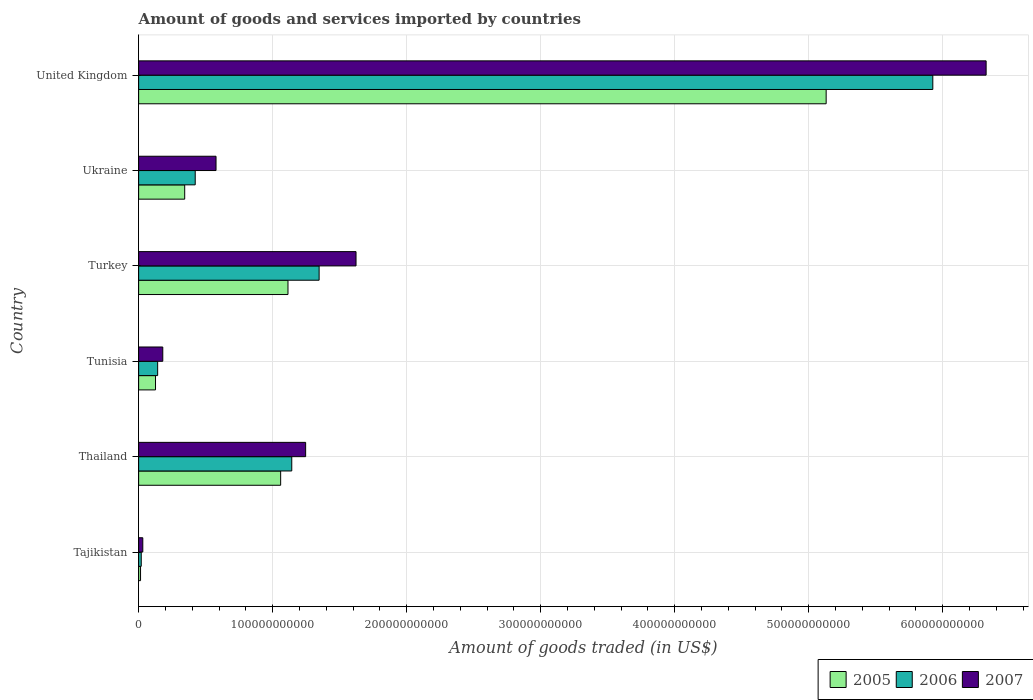Are the number of bars on each tick of the Y-axis equal?
Offer a very short reply. Yes. How many bars are there on the 1st tick from the top?
Provide a short and direct response. 3. How many bars are there on the 4th tick from the bottom?
Your answer should be compact. 3. What is the label of the 2nd group of bars from the top?
Keep it short and to the point. Ukraine. In how many cases, is the number of bars for a given country not equal to the number of legend labels?
Offer a terse response. 0. What is the total amount of goods and services imported in 2005 in Tunisia?
Give a very brief answer. 1.26e+1. Across all countries, what is the maximum total amount of goods and services imported in 2007?
Your response must be concise. 6.32e+11. Across all countries, what is the minimum total amount of goods and services imported in 2005?
Offer a terse response. 1.43e+09. In which country was the total amount of goods and services imported in 2007 minimum?
Offer a very short reply. Tajikistan. What is the total total amount of goods and services imported in 2005 in the graph?
Offer a very short reply. 7.79e+11. What is the difference between the total amount of goods and services imported in 2007 in Tunisia and that in Ukraine?
Provide a succinct answer. -3.97e+1. What is the difference between the total amount of goods and services imported in 2006 in Turkey and the total amount of goods and services imported in 2005 in Tajikistan?
Offer a terse response. 1.33e+11. What is the average total amount of goods and services imported in 2007 per country?
Provide a succinct answer. 1.66e+11. What is the difference between the total amount of goods and services imported in 2006 and total amount of goods and services imported in 2005 in Tajikistan?
Give a very brief answer. 5.24e+08. What is the ratio of the total amount of goods and services imported in 2007 in Ukraine to that in United Kingdom?
Your answer should be compact. 0.09. What is the difference between the highest and the second highest total amount of goods and services imported in 2007?
Offer a terse response. 4.70e+11. What is the difference between the highest and the lowest total amount of goods and services imported in 2005?
Make the answer very short. 5.12e+11. In how many countries, is the total amount of goods and services imported in 2005 greater than the average total amount of goods and services imported in 2005 taken over all countries?
Give a very brief answer. 1. What does the 1st bar from the top in United Kingdom represents?
Make the answer very short. 2007. Is it the case that in every country, the sum of the total amount of goods and services imported in 2007 and total amount of goods and services imported in 2006 is greater than the total amount of goods and services imported in 2005?
Offer a very short reply. Yes. Are all the bars in the graph horizontal?
Give a very brief answer. Yes. What is the difference between two consecutive major ticks on the X-axis?
Provide a succinct answer. 1.00e+11. Does the graph contain any zero values?
Provide a short and direct response. No. Does the graph contain grids?
Keep it short and to the point. Yes. Where does the legend appear in the graph?
Keep it short and to the point. Bottom right. How are the legend labels stacked?
Give a very brief answer. Horizontal. What is the title of the graph?
Offer a very short reply. Amount of goods and services imported by countries. Does "1999" appear as one of the legend labels in the graph?
Provide a succinct answer. No. What is the label or title of the X-axis?
Make the answer very short. Amount of goods traded (in US$). What is the label or title of the Y-axis?
Offer a terse response. Country. What is the Amount of goods traded (in US$) of 2005 in Tajikistan?
Keep it short and to the point. 1.43e+09. What is the Amount of goods traded (in US$) of 2006 in Tajikistan?
Your response must be concise. 1.95e+09. What is the Amount of goods traded (in US$) of 2007 in Tajikistan?
Your response must be concise. 3.12e+09. What is the Amount of goods traded (in US$) of 2005 in Thailand?
Make the answer very short. 1.06e+11. What is the Amount of goods traded (in US$) of 2006 in Thailand?
Give a very brief answer. 1.14e+11. What is the Amount of goods traded (in US$) in 2007 in Thailand?
Your response must be concise. 1.25e+11. What is the Amount of goods traded (in US$) in 2005 in Tunisia?
Your response must be concise. 1.26e+1. What is the Amount of goods traded (in US$) of 2006 in Tunisia?
Offer a very short reply. 1.42e+1. What is the Amount of goods traded (in US$) of 2007 in Tunisia?
Your response must be concise. 1.80e+1. What is the Amount of goods traded (in US$) of 2005 in Turkey?
Offer a very short reply. 1.11e+11. What is the Amount of goods traded (in US$) in 2006 in Turkey?
Keep it short and to the point. 1.35e+11. What is the Amount of goods traded (in US$) of 2007 in Turkey?
Give a very brief answer. 1.62e+11. What is the Amount of goods traded (in US$) in 2005 in Ukraine?
Provide a succinct answer. 3.44e+1. What is the Amount of goods traded (in US$) of 2006 in Ukraine?
Your answer should be compact. 4.22e+1. What is the Amount of goods traded (in US$) of 2007 in Ukraine?
Your answer should be very brief. 5.78e+1. What is the Amount of goods traded (in US$) in 2005 in United Kingdom?
Ensure brevity in your answer.  5.13e+11. What is the Amount of goods traded (in US$) of 2006 in United Kingdom?
Keep it short and to the point. 5.93e+11. What is the Amount of goods traded (in US$) in 2007 in United Kingdom?
Keep it short and to the point. 6.32e+11. Across all countries, what is the maximum Amount of goods traded (in US$) in 2005?
Provide a short and direct response. 5.13e+11. Across all countries, what is the maximum Amount of goods traded (in US$) in 2006?
Provide a succinct answer. 5.93e+11. Across all countries, what is the maximum Amount of goods traded (in US$) in 2007?
Provide a succinct answer. 6.32e+11. Across all countries, what is the minimum Amount of goods traded (in US$) in 2005?
Provide a succinct answer. 1.43e+09. Across all countries, what is the minimum Amount of goods traded (in US$) of 2006?
Provide a succinct answer. 1.95e+09. Across all countries, what is the minimum Amount of goods traded (in US$) in 2007?
Your answer should be compact. 3.12e+09. What is the total Amount of goods traded (in US$) in 2005 in the graph?
Ensure brevity in your answer.  7.79e+11. What is the total Amount of goods traded (in US$) in 2006 in the graph?
Your answer should be very brief. 9.00e+11. What is the total Amount of goods traded (in US$) in 2007 in the graph?
Ensure brevity in your answer.  9.98e+11. What is the difference between the Amount of goods traded (in US$) of 2005 in Tajikistan and that in Thailand?
Make the answer very short. -1.05e+11. What is the difference between the Amount of goods traded (in US$) in 2006 in Tajikistan and that in Thailand?
Keep it short and to the point. -1.12e+11. What is the difference between the Amount of goods traded (in US$) in 2007 in Tajikistan and that in Thailand?
Make the answer very short. -1.21e+11. What is the difference between the Amount of goods traded (in US$) in 2005 in Tajikistan and that in Tunisia?
Offer a terse response. -1.12e+1. What is the difference between the Amount of goods traded (in US$) of 2006 in Tajikistan and that in Tunisia?
Your answer should be compact. -1.22e+1. What is the difference between the Amount of goods traded (in US$) of 2007 in Tajikistan and that in Tunisia?
Offer a terse response. -1.49e+1. What is the difference between the Amount of goods traded (in US$) in 2005 in Tajikistan and that in Turkey?
Provide a short and direct response. -1.10e+11. What is the difference between the Amount of goods traded (in US$) in 2006 in Tajikistan and that in Turkey?
Your answer should be very brief. -1.33e+11. What is the difference between the Amount of goods traded (in US$) of 2007 in Tajikistan and that in Turkey?
Make the answer very short. -1.59e+11. What is the difference between the Amount of goods traded (in US$) of 2005 in Tajikistan and that in Ukraine?
Your answer should be compact. -3.29e+1. What is the difference between the Amount of goods traded (in US$) of 2006 in Tajikistan and that in Ukraine?
Your answer should be compact. -4.03e+1. What is the difference between the Amount of goods traded (in US$) of 2007 in Tajikistan and that in Ukraine?
Your answer should be compact. -5.46e+1. What is the difference between the Amount of goods traded (in US$) of 2005 in Tajikistan and that in United Kingdom?
Ensure brevity in your answer.  -5.12e+11. What is the difference between the Amount of goods traded (in US$) in 2006 in Tajikistan and that in United Kingdom?
Give a very brief answer. -5.91e+11. What is the difference between the Amount of goods traded (in US$) in 2007 in Tajikistan and that in United Kingdom?
Offer a very short reply. -6.29e+11. What is the difference between the Amount of goods traded (in US$) in 2005 in Thailand and that in Tunisia?
Provide a short and direct response. 9.34e+1. What is the difference between the Amount of goods traded (in US$) in 2006 in Thailand and that in Tunisia?
Give a very brief answer. 1.00e+11. What is the difference between the Amount of goods traded (in US$) in 2007 in Thailand and that in Tunisia?
Your response must be concise. 1.07e+11. What is the difference between the Amount of goods traded (in US$) of 2005 in Thailand and that in Turkey?
Offer a very short reply. -5.47e+09. What is the difference between the Amount of goods traded (in US$) in 2006 in Thailand and that in Turkey?
Your answer should be very brief. -2.04e+1. What is the difference between the Amount of goods traded (in US$) in 2007 in Thailand and that in Turkey?
Your answer should be compact. -3.76e+1. What is the difference between the Amount of goods traded (in US$) of 2005 in Thailand and that in Ukraine?
Your answer should be compact. 7.16e+1. What is the difference between the Amount of goods traded (in US$) of 2006 in Thailand and that in Ukraine?
Offer a terse response. 7.20e+1. What is the difference between the Amount of goods traded (in US$) in 2007 in Thailand and that in Ukraine?
Give a very brief answer. 6.69e+1. What is the difference between the Amount of goods traded (in US$) of 2005 in Thailand and that in United Kingdom?
Provide a succinct answer. -4.07e+11. What is the difference between the Amount of goods traded (in US$) of 2006 in Thailand and that in United Kingdom?
Offer a very short reply. -4.78e+11. What is the difference between the Amount of goods traded (in US$) of 2007 in Thailand and that in United Kingdom?
Offer a very short reply. -5.08e+11. What is the difference between the Amount of goods traded (in US$) in 2005 in Tunisia and that in Turkey?
Keep it short and to the point. -9.89e+1. What is the difference between the Amount of goods traded (in US$) in 2006 in Tunisia and that in Turkey?
Offer a very short reply. -1.20e+11. What is the difference between the Amount of goods traded (in US$) in 2007 in Tunisia and that in Turkey?
Your response must be concise. -1.44e+11. What is the difference between the Amount of goods traded (in US$) of 2005 in Tunisia and that in Ukraine?
Offer a very short reply. -2.18e+1. What is the difference between the Amount of goods traded (in US$) of 2006 in Tunisia and that in Ukraine?
Provide a short and direct response. -2.80e+1. What is the difference between the Amount of goods traded (in US$) of 2007 in Tunisia and that in Ukraine?
Your answer should be compact. -3.97e+1. What is the difference between the Amount of goods traded (in US$) of 2005 in Tunisia and that in United Kingdom?
Offer a terse response. -5.00e+11. What is the difference between the Amount of goods traded (in US$) in 2006 in Tunisia and that in United Kingdom?
Offer a terse response. -5.78e+11. What is the difference between the Amount of goods traded (in US$) in 2007 in Tunisia and that in United Kingdom?
Give a very brief answer. -6.14e+11. What is the difference between the Amount of goods traded (in US$) of 2005 in Turkey and that in Ukraine?
Offer a very short reply. 7.71e+1. What is the difference between the Amount of goods traded (in US$) of 2006 in Turkey and that in Ukraine?
Ensure brevity in your answer.  9.25e+1. What is the difference between the Amount of goods traded (in US$) of 2007 in Turkey and that in Ukraine?
Offer a terse response. 1.04e+11. What is the difference between the Amount of goods traded (in US$) of 2005 in Turkey and that in United Kingdom?
Give a very brief answer. -4.02e+11. What is the difference between the Amount of goods traded (in US$) of 2006 in Turkey and that in United Kingdom?
Ensure brevity in your answer.  -4.58e+11. What is the difference between the Amount of goods traded (in US$) of 2007 in Turkey and that in United Kingdom?
Give a very brief answer. -4.70e+11. What is the difference between the Amount of goods traded (in US$) of 2005 in Ukraine and that in United Kingdom?
Your response must be concise. -4.79e+11. What is the difference between the Amount of goods traded (in US$) of 2006 in Ukraine and that in United Kingdom?
Your response must be concise. -5.50e+11. What is the difference between the Amount of goods traded (in US$) in 2007 in Ukraine and that in United Kingdom?
Your answer should be compact. -5.75e+11. What is the difference between the Amount of goods traded (in US$) of 2005 in Tajikistan and the Amount of goods traded (in US$) of 2006 in Thailand?
Your response must be concise. -1.13e+11. What is the difference between the Amount of goods traded (in US$) of 2005 in Tajikistan and the Amount of goods traded (in US$) of 2007 in Thailand?
Give a very brief answer. -1.23e+11. What is the difference between the Amount of goods traded (in US$) in 2006 in Tajikistan and the Amount of goods traded (in US$) in 2007 in Thailand?
Provide a short and direct response. -1.23e+11. What is the difference between the Amount of goods traded (in US$) of 2005 in Tajikistan and the Amount of goods traded (in US$) of 2006 in Tunisia?
Keep it short and to the point. -1.28e+1. What is the difference between the Amount of goods traded (in US$) in 2005 in Tajikistan and the Amount of goods traded (in US$) in 2007 in Tunisia?
Provide a short and direct response. -1.66e+1. What is the difference between the Amount of goods traded (in US$) of 2006 in Tajikistan and the Amount of goods traded (in US$) of 2007 in Tunisia?
Ensure brevity in your answer.  -1.61e+1. What is the difference between the Amount of goods traded (in US$) of 2005 in Tajikistan and the Amount of goods traded (in US$) of 2006 in Turkey?
Offer a terse response. -1.33e+11. What is the difference between the Amount of goods traded (in US$) of 2005 in Tajikistan and the Amount of goods traded (in US$) of 2007 in Turkey?
Make the answer very short. -1.61e+11. What is the difference between the Amount of goods traded (in US$) of 2006 in Tajikistan and the Amount of goods traded (in US$) of 2007 in Turkey?
Make the answer very short. -1.60e+11. What is the difference between the Amount of goods traded (in US$) in 2005 in Tajikistan and the Amount of goods traded (in US$) in 2006 in Ukraine?
Keep it short and to the point. -4.08e+1. What is the difference between the Amount of goods traded (in US$) of 2005 in Tajikistan and the Amount of goods traded (in US$) of 2007 in Ukraine?
Offer a very short reply. -5.63e+1. What is the difference between the Amount of goods traded (in US$) in 2006 in Tajikistan and the Amount of goods traded (in US$) in 2007 in Ukraine?
Offer a very short reply. -5.58e+1. What is the difference between the Amount of goods traded (in US$) in 2005 in Tajikistan and the Amount of goods traded (in US$) in 2006 in United Kingdom?
Your answer should be very brief. -5.91e+11. What is the difference between the Amount of goods traded (in US$) in 2005 in Tajikistan and the Amount of goods traded (in US$) in 2007 in United Kingdom?
Your answer should be compact. -6.31e+11. What is the difference between the Amount of goods traded (in US$) in 2006 in Tajikistan and the Amount of goods traded (in US$) in 2007 in United Kingdom?
Your answer should be compact. -6.30e+11. What is the difference between the Amount of goods traded (in US$) in 2005 in Thailand and the Amount of goods traded (in US$) in 2006 in Tunisia?
Ensure brevity in your answer.  9.18e+1. What is the difference between the Amount of goods traded (in US$) in 2005 in Thailand and the Amount of goods traded (in US$) in 2007 in Tunisia?
Ensure brevity in your answer.  8.80e+1. What is the difference between the Amount of goods traded (in US$) of 2006 in Thailand and the Amount of goods traded (in US$) of 2007 in Tunisia?
Make the answer very short. 9.62e+1. What is the difference between the Amount of goods traded (in US$) in 2005 in Thailand and the Amount of goods traded (in US$) in 2006 in Turkey?
Ensure brevity in your answer.  -2.87e+1. What is the difference between the Amount of goods traded (in US$) in 2005 in Thailand and the Amount of goods traded (in US$) in 2007 in Turkey?
Your answer should be very brief. -5.62e+1. What is the difference between the Amount of goods traded (in US$) of 2006 in Thailand and the Amount of goods traded (in US$) of 2007 in Turkey?
Your answer should be very brief. -4.79e+1. What is the difference between the Amount of goods traded (in US$) in 2005 in Thailand and the Amount of goods traded (in US$) in 2006 in Ukraine?
Provide a succinct answer. 6.38e+1. What is the difference between the Amount of goods traded (in US$) in 2005 in Thailand and the Amount of goods traded (in US$) in 2007 in Ukraine?
Offer a terse response. 4.82e+1. What is the difference between the Amount of goods traded (in US$) in 2006 in Thailand and the Amount of goods traded (in US$) in 2007 in Ukraine?
Provide a short and direct response. 5.65e+1. What is the difference between the Amount of goods traded (in US$) of 2005 in Thailand and the Amount of goods traded (in US$) of 2006 in United Kingdom?
Keep it short and to the point. -4.87e+11. What is the difference between the Amount of goods traded (in US$) of 2005 in Thailand and the Amount of goods traded (in US$) of 2007 in United Kingdom?
Offer a terse response. -5.26e+11. What is the difference between the Amount of goods traded (in US$) in 2006 in Thailand and the Amount of goods traded (in US$) in 2007 in United Kingdom?
Your answer should be compact. -5.18e+11. What is the difference between the Amount of goods traded (in US$) of 2005 in Tunisia and the Amount of goods traded (in US$) of 2006 in Turkey?
Provide a succinct answer. -1.22e+11. What is the difference between the Amount of goods traded (in US$) in 2005 in Tunisia and the Amount of goods traded (in US$) in 2007 in Turkey?
Your answer should be very brief. -1.50e+11. What is the difference between the Amount of goods traded (in US$) in 2006 in Tunisia and the Amount of goods traded (in US$) in 2007 in Turkey?
Offer a terse response. -1.48e+11. What is the difference between the Amount of goods traded (in US$) in 2005 in Tunisia and the Amount of goods traded (in US$) in 2006 in Ukraine?
Offer a terse response. -2.96e+1. What is the difference between the Amount of goods traded (in US$) of 2005 in Tunisia and the Amount of goods traded (in US$) of 2007 in Ukraine?
Ensure brevity in your answer.  -4.52e+1. What is the difference between the Amount of goods traded (in US$) of 2006 in Tunisia and the Amount of goods traded (in US$) of 2007 in Ukraine?
Your answer should be compact. -4.36e+1. What is the difference between the Amount of goods traded (in US$) in 2005 in Tunisia and the Amount of goods traded (in US$) in 2006 in United Kingdom?
Offer a very short reply. -5.80e+11. What is the difference between the Amount of goods traded (in US$) in 2005 in Tunisia and the Amount of goods traded (in US$) in 2007 in United Kingdom?
Provide a succinct answer. -6.20e+11. What is the difference between the Amount of goods traded (in US$) of 2006 in Tunisia and the Amount of goods traded (in US$) of 2007 in United Kingdom?
Give a very brief answer. -6.18e+11. What is the difference between the Amount of goods traded (in US$) of 2005 in Turkey and the Amount of goods traded (in US$) of 2006 in Ukraine?
Give a very brief answer. 6.92e+1. What is the difference between the Amount of goods traded (in US$) of 2005 in Turkey and the Amount of goods traded (in US$) of 2007 in Ukraine?
Give a very brief answer. 5.37e+1. What is the difference between the Amount of goods traded (in US$) in 2006 in Turkey and the Amount of goods traded (in US$) in 2007 in Ukraine?
Provide a succinct answer. 7.69e+1. What is the difference between the Amount of goods traded (in US$) in 2005 in Turkey and the Amount of goods traded (in US$) in 2006 in United Kingdom?
Your answer should be compact. -4.81e+11. What is the difference between the Amount of goods traded (in US$) of 2005 in Turkey and the Amount of goods traded (in US$) of 2007 in United Kingdom?
Your response must be concise. -5.21e+11. What is the difference between the Amount of goods traded (in US$) in 2006 in Turkey and the Amount of goods traded (in US$) in 2007 in United Kingdom?
Provide a short and direct response. -4.98e+11. What is the difference between the Amount of goods traded (in US$) of 2005 in Ukraine and the Amount of goods traded (in US$) of 2006 in United Kingdom?
Provide a short and direct response. -5.58e+11. What is the difference between the Amount of goods traded (in US$) of 2005 in Ukraine and the Amount of goods traded (in US$) of 2007 in United Kingdom?
Offer a terse response. -5.98e+11. What is the difference between the Amount of goods traded (in US$) in 2006 in Ukraine and the Amount of goods traded (in US$) in 2007 in United Kingdom?
Your response must be concise. -5.90e+11. What is the average Amount of goods traded (in US$) in 2005 per country?
Offer a terse response. 1.30e+11. What is the average Amount of goods traded (in US$) of 2006 per country?
Your response must be concise. 1.50e+11. What is the average Amount of goods traded (in US$) of 2007 per country?
Keep it short and to the point. 1.66e+11. What is the difference between the Amount of goods traded (in US$) of 2005 and Amount of goods traded (in US$) of 2006 in Tajikistan?
Make the answer very short. -5.24e+08. What is the difference between the Amount of goods traded (in US$) in 2005 and Amount of goods traded (in US$) in 2007 in Tajikistan?
Make the answer very short. -1.68e+09. What is the difference between the Amount of goods traded (in US$) of 2006 and Amount of goods traded (in US$) of 2007 in Tajikistan?
Ensure brevity in your answer.  -1.16e+09. What is the difference between the Amount of goods traded (in US$) in 2005 and Amount of goods traded (in US$) in 2006 in Thailand?
Provide a short and direct response. -8.29e+09. What is the difference between the Amount of goods traded (in US$) of 2005 and Amount of goods traded (in US$) of 2007 in Thailand?
Your answer should be very brief. -1.86e+1. What is the difference between the Amount of goods traded (in US$) in 2006 and Amount of goods traded (in US$) in 2007 in Thailand?
Your answer should be very brief. -1.03e+1. What is the difference between the Amount of goods traded (in US$) in 2005 and Amount of goods traded (in US$) in 2006 in Tunisia?
Offer a terse response. -1.61e+09. What is the difference between the Amount of goods traded (in US$) of 2005 and Amount of goods traded (in US$) of 2007 in Tunisia?
Make the answer very short. -5.43e+09. What is the difference between the Amount of goods traded (in US$) of 2006 and Amount of goods traded (in US$) of 2007 in Tunisia?
Offer a terse response. -3.82e+09. What is the difference between the Amount of goods traded (in US$) in 2005 and Amount of goods traded (in US$) in 2006 in Turkey?
Offer a terse response. -2.32e+1. What is the difference between the Amount of goods traded (in US$) in 2005 and Amount of goods traded (in US$) in 2007 in Turkey?
Make the answer very short. -5.08e+1. What is the difference between the Amount of goods traded (in US$) of 2006 and Amount of goods traded (in US$) of 2007 in Turkey?
Your answer should be compact. -2.75e+1. What is the difference between the Amount of goods traded (in US$) of 2005 and Amount of goods traded (in US$) of 2006 in Ukraine?
Keep it short and to the point. -7.84e+09. What is the difference between the Amount of goods traded (in US$) in 2005 and Amount of goods traded (in US$) in 2007 in Ukraine?
Provide a succinct answer. -2.34e+1. What is the difference between the Amount of goods traded (in US$) in 2006 and Amount of goods traded (in US$) in 2007 in Ukraine?
Give a very brief answer. -1.55e+1. What is the difference between the Amount of goods traded (in US$) in 2005 and Amount of goods traded (in US$) in 2006 in United Kingdom?
Offer a terse response. -7.96e+1. What is the difference between the Amount of goods traded (in US$) of 2005 and Amount of goods traded (in US$) of 2007 in United Kingdom?
Provide a short and direct response. -1.19e+11. What is the difference between the Amount of goods traded (in US$) in 2006 and Amount of goods traded (in US$) in 2007 in United Kingdom?
Provide a short and direct response. -3.98e+1. What is the ratio of the Amount of goods traded (in US$) of 2005 in Tajikistan to that in Thailand?
Offer a very short reply. 0.01. What is the ratio of the Amount of goods traded (in US$) in 2006 in Tajikistan to that in Thailand?
Provide a succinct answer. 0.02. What is the ratio of the Amount of goods traded (in US$) in 2007 in Tajikistan to that in Thailand?
Your response must be concise. 0.03. What is the ratio of the Amount of goods traded (in US$) of 2005 in Tajikistan to that in Tunisia?
Keep it short and to the point. 0.11. What is the ratio of the Amount of goods traded (in US$) in 2006 in Tajikistan to that in Tunisia?
Offer a very short reply. 0.14. What is the ratio of the Amount of goods traded (in US$) in 2007 in Tajikistan to that in Tunisia?
Your response must be concise. 0.17. What is the ratio of the Amount of goods traded (in US$) in 2005 in Tajikistan to that in Turkey?
Offer a terse response. 0.01. What is the ratio of the Amount of goods traded (in US$) of 2006 in Tajikistan to that in Turkey?
Your response must be concise. 0.01. What is the ratio of the Amount of goods traded (in US$) of 2007 in Tajikistan to that in Turkey?
Provide a short and direct response. 0.02. What is the ratio of the Amount of goods traded (in US$) in 2005 in Tajikistan to that in Ukraine?
Ensure brevity in your answer.  0.04. What is the ratio of the Amount of goods traded (in US$) in 2006 in Tajikistan to that in Ukraine?
Your answer should be very brief. 0.05. What is the ratio of the Amount of goods traded (in US$) of 2007 in Tajikistan to that in Ukraine?
Keep it short and to the point. 0.05. What is the ratio of the Amount of goods traded (in US$) of 2005 in Tajikistan to that in United Kingdom?
Offer a very short reply. 0. What is the ratio of the Amount of goods traded (in US$) in 2006 in Tajikistan to that in United Kingdom?
Offer a terse response. 0. What is the ratio of the Amount of goods traded (in US$) in 2007 in Tajikistan to that in United Kingdom?
Offer a terse response. 0. What is the ratio of the Amount of goods traded (in US$) in 2005 in Thailand to that in Tunisia?
Offer a terse response. 8.41. What is the ratio of the Amount of goods traded (in US$) in 2006 in Thailand to that in Tunisia?
Give a very brief answer. 8.05. What is the ratio of the Amount of goods traded (in US$) in 2007 in Thailand to that in Tunisia?
Your answer should be very brief. 6.91. What is the ratio of the Amount of goods traded (in US$) in 2005 in Thailand to that in Turkey?
Offer a terse response. 0.95. What is the ratio of the Amount of goods traded (in US$) in 2006 in Thailand to that in Turkey?
Ensure brevity in your answer.  0.85. What is the ratio of the Amount of goods traded (in US$) in 2007 in Thailand to that in Turkey?
Make the answer very short. 0.77. What is the ratio of the Amount of goods traded (in US$) of 2005 in Thailand to that in Ukraine?
Your answer should be very brief. 3.08. What is the ratio of the Amount of goods traded (in US$) of 2006 in Thailand to that in Ukraine?
Your answer should be very brief. 2.71. What is the ratio of the Amount of goods traded (in US$) in 2007 in Thailand to that in Ukraine?
Your response must be concise. 2.16. What is the ratio of the Amount of goods traded (in US$) of 2005 in Thailand to that in United Kingdom?
Your response must be concise. 0.21. What is the ratio of the Amount of goods traded (in US$) in 2006 in Thailand to that in United Kingdom?
Provide a succinct answer. 0.19. What is the ratio of the Amount of goods traded (in US$) in 2007 in Thailand to that in United Kingdom?
Provide a succinct answer. 0.2. What is the ratio of the Amount of goods traded (in US$) of 2005 in Tunisia to that in Turkey?
Offer a very short reply. 0.11. What is the ratio of the Amount of goods traded (in US$) of 2006 in Tunisia to that in Turkey?
Provide a succinct answer. 0.11. What is the ratio of the Amount of goods traded (in US$) in 2007 in Tunisia to that in Turkey?
Your answer should be very brief. 0.11. What is the ratio of the Amount of goods traded (in US$) of 2005 in Tunisia to that in Ukraine?
Keep it short and to the point. 0.37. What is the ratio of the Amount of goods traded (in US$) of 2006 in Tunisia to that in Ukraine?
Your answer should be very brief. 0.34. What is the ratio of the Amount of goods traded (in US$) in 2007 in Tunisia to that in Ukraine?
Ensure brevity in your answer.  0.31. What is the ratio of the Amount of goods traded (in US$) in 2005 in Tunisia to that in United Kingdom?
Offer a very short reply. 0.02. What is the ratio of the Amount of goods traded (in US$) in 2006 in Tunisia to that in United Kingdom?
Keep it short and to the point. 0.02. What is the ratio of the Amount of goods traded (in US$) of 2007 in Tunisia to that in United Kingdom?
Provide a succinct answer. 0.03. What is the ratio of the Amount of goods traded (in US$) in 2005 in Turkey to that in Ukraine?
Offer a terse response. 3.24. What is the ratio of the Amount of goods traded (in US$) in 2006 in Turkey to that in Ukraine?
Your answer should be compact. 3.19. What is the ratio of the Amount of goods traded (in US$) of 2007 in Turkey to that in Ukraine?
Give a very brief answer. 2.81. What is the ratio of the Amount of goods traded (in US$) in 2005 in Turkey to that in United Kingdom?
Provide a succinct answer. 0.22. What is the ratio of the Amount of goods traded (in US$) in 2006 in Turkey to that in United Kingdom?
Offer a terse response. 0.23. What is the ratio of the Amount of goods traded (in US$) of 2007 in Turkey to that in United Kingdom?
Ensure brevity in your answer.  0.26. What is the ratio of the Amount of goods traded (in US$) of 2005 in Ukraine to that in United Kingdom?
Your answer should be compact. 0.07. What is the ratio of the Amount of goods traded (in US$) in 2006 in Ukraine to that in United Kingdom?
Offer a terse response. 0.07. What is the ratio of the Amount of goods traded (in US$) in 2007 in Ukraine to that in United Kingdom?
Ensure brevity in your answer.  0.09. What is the difference between the highest and the second highest Amount of goods traded (in US$) in 2005?
Give a very brief answer. 4.02e+11. What is the difference between the highest and the second highest Amount of goods traded (in US$) of 2006?
Your answer should be compact. 4.58e+11. What is the difference between the highest and the second highest Amount of goods traded (in US$) of 2007?
Provide a succinct answer. 4.70e+11. What is the difference between the highest and the lowest Amount of goods traded (in US$) in 2005?
Provide a succinct answer. 5.12e+11. What is the difference between the highest and the lowest Amount of goods traded (in US$) in 2006?
Your answer should be compact. 5.91e+11. What is the difference between the highest and the lowest Amount of goods traded (in US$) in 2007?
Ensure brevity in your answer.  6.29e+11. 